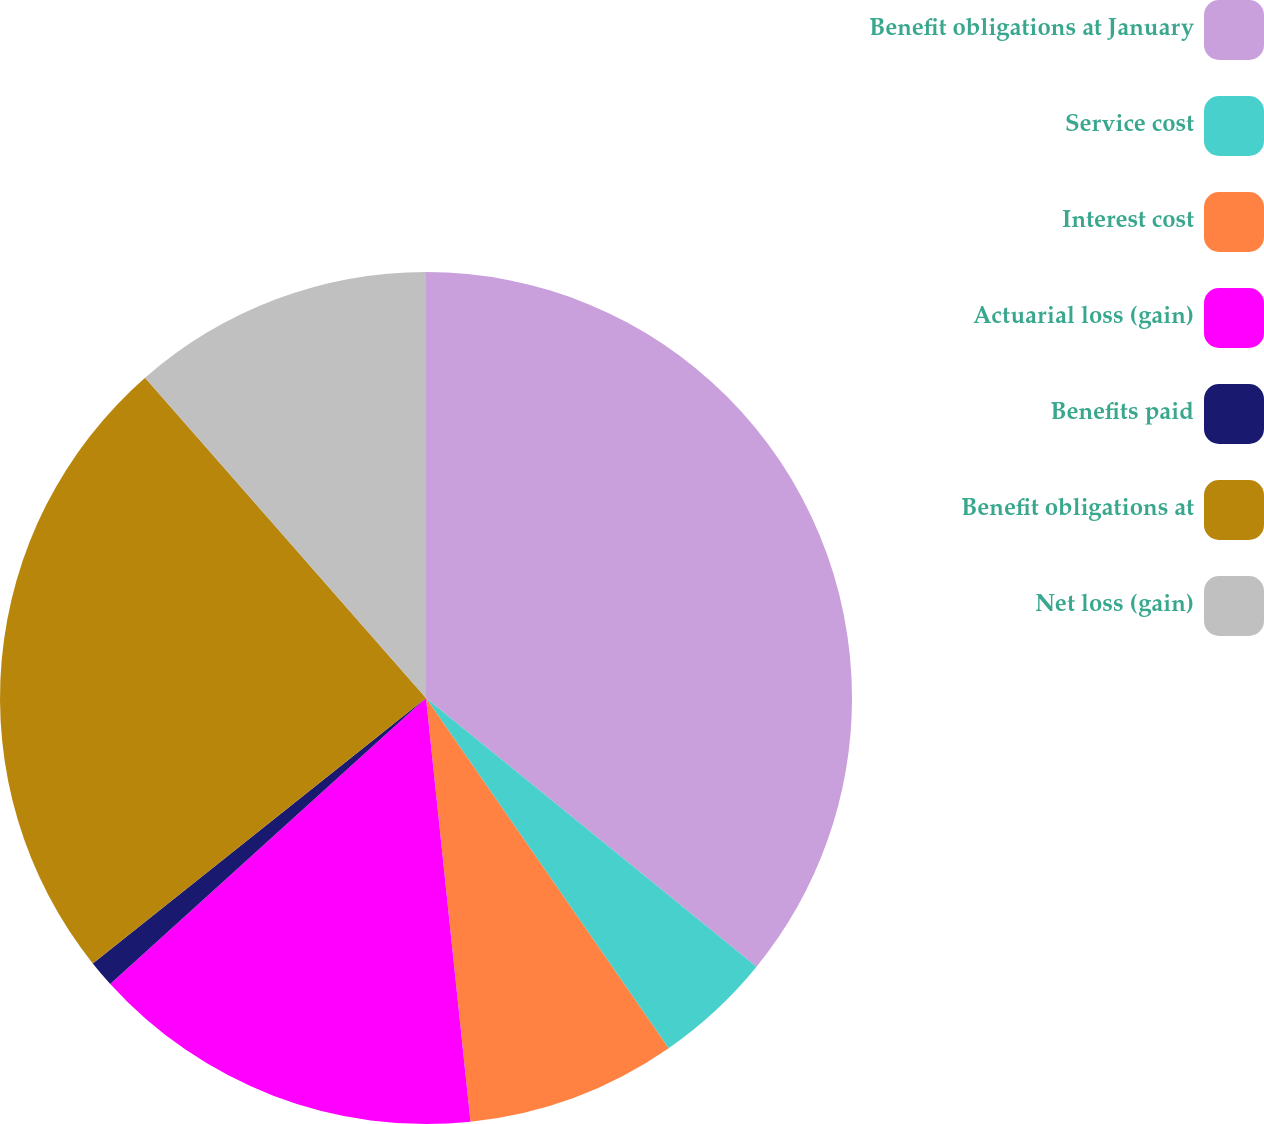Convert chart to OTSL. <chart><loc_0><loc_0><loc_500><loc_500><pie_chart><fcel>Benefit obligations at January<fcel>Service cost<fcel>Interest cost<fcel>Actuarial loss (gain)<fcel>Benefits paid<fcel>Benefit obligations at<fcel>Net loss (gain)<nl><fcel>35.86%<fcel>4.49%<fcel>7.98%<fcel>14.95%<fcel>1.01%<fcel>24.24%<fcel>11.46%<nl></chart> 